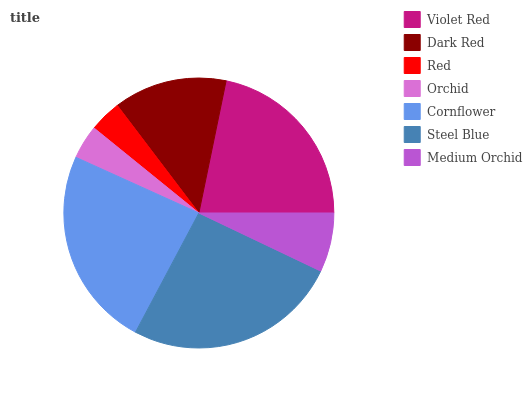Is Red the minimum?
Answer yes or no. Yes. Is Steel Blue the maximum?
Answer yes or no. Yes. Is Dark Red the minimum?
Answer yes or no. No. Is Dark Red the maximum?
Answer yes or no. No. Is Violet Red greater than Dark Red?
Answer yes or no. Yes. Is Dark Red less than Violet Red?
Answer yes or no. Yes. Is Dark Red greater than Violet Red?
Answer yes or no. No. Is Violet Red less than Dark Red?
Answer yes or no. No. Is Dark Red the high median?
Answer yes or no. Yes. Is Dark Red the low median?
Answer yes or no. Yes. Is Red the high median?
Answer yes or no. No. Is Cornflower the low median?
Answer yes or no. No. 